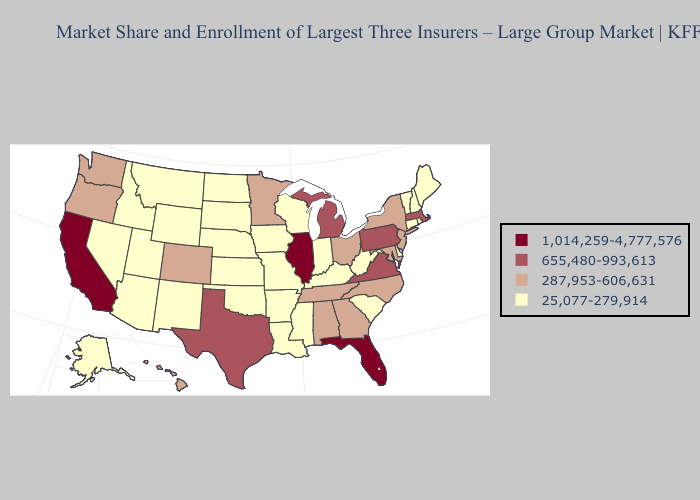Does Michigan have the lowest value in the MidWest?
Give a very brief answer. No. Does Texas have the lowest value in the South?
Quick response, please. No. Does South Carolina have a higher value than Alabama?
Be succinct. No. What is the value of Hawaii?
Give a very brief answer. 287,953-606,631. What is the highest value in states that border Nebraska?
Be succinct. 287,953-606,631. What is the highest value in states that border Michigan?
Answer briefly. 287,953-606,631. What is the highest value in states that border Ohio?
Keep it brief. 655,480-993,613. Does Arizona have a higher value than Arkansas?
Short answer required. No. What is the highest value in the USA?
Quick response, please. 1,014,259-4,777,576. Does Maryland have the highest value in the USA?
Write a very short answer. No. Name the states that have a value in the range 25,077-279,914?
Short answer required. Alaska, Arizona, Arkansas, Connecticut, Delaware, Idaho, Indiana, Iowa, Kansas, Kentucky, Louisiana, Maine, Mississippi, Missouri, Montana, Nebraska, Nevada, New Hampshire, New Mexico, North Dakota, Oklahoma, Rhode Island, South Carolina, South Dakota, Utah, Vermont, West Virginia, Wisconsin, Wyoming. Does New Mexico have the lowest value in the West?
Keep it brief. Yes. Among the states that border West Virginia , which have the highest value?
Concise answer only. Pennsylvania, Virginia. What is the value of Oklahoma?
Short answer required. 25,077-279,914. What is the value of Iowa?
Write a very short answer. 25,077-279,914. 